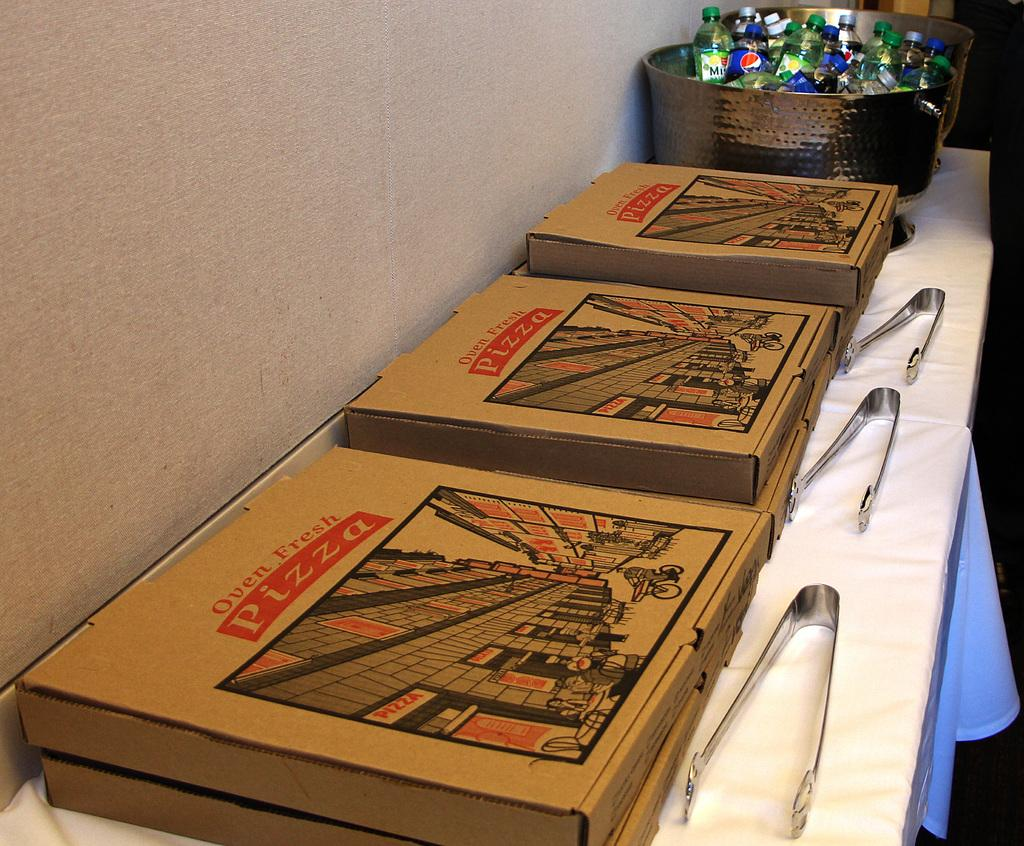Provide a one-sentence caption for the provided image. Boxes of Ozen Fresh Pizza and a basket filled with soft drinks on a buffet table. 